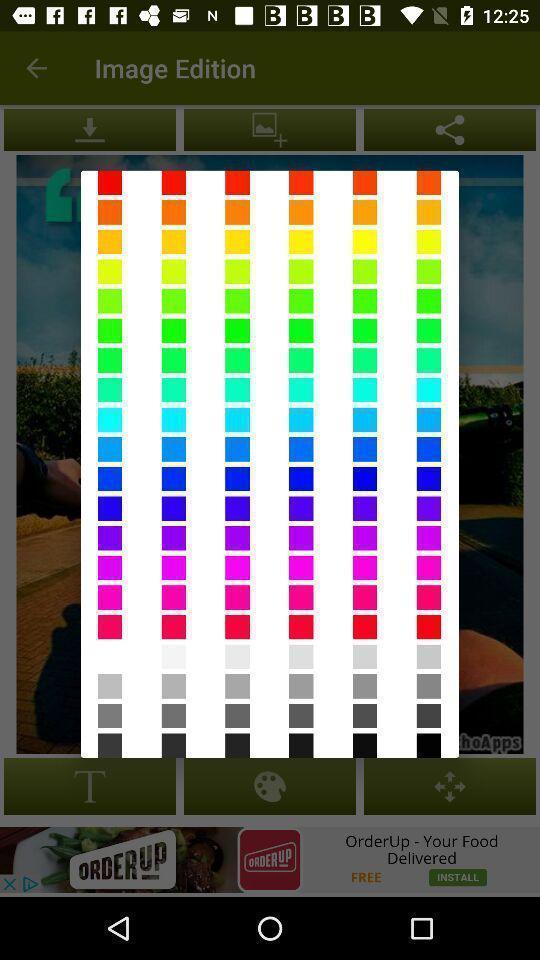Provide a textual representation of this image. Pop up showing various shades of colors. 